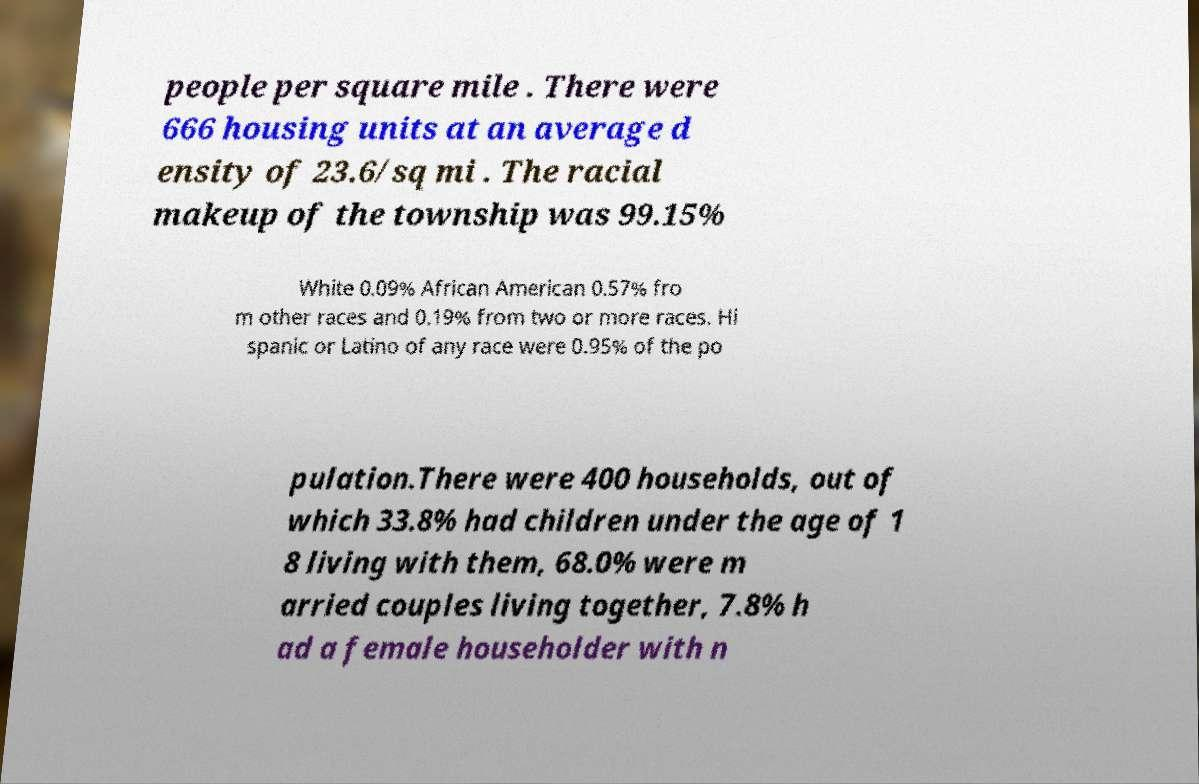I need the written content from this picture converted into text. Can you do that? people per square mile . There were 666 housing units at an average d ensity of 23.6/sq mi . The racial makeup of the township was 99.15% White 0.09% African American 0.57% fro m other races and 0.19% from two or more races. Hi spanic or Latino of any race were 0.95% of the po pulation.There were 400 households, out of which 33.8% had children under the age of 1 8 living with them, 68.0% were m arried couples living together, 7.8% h ad a female householder with n 